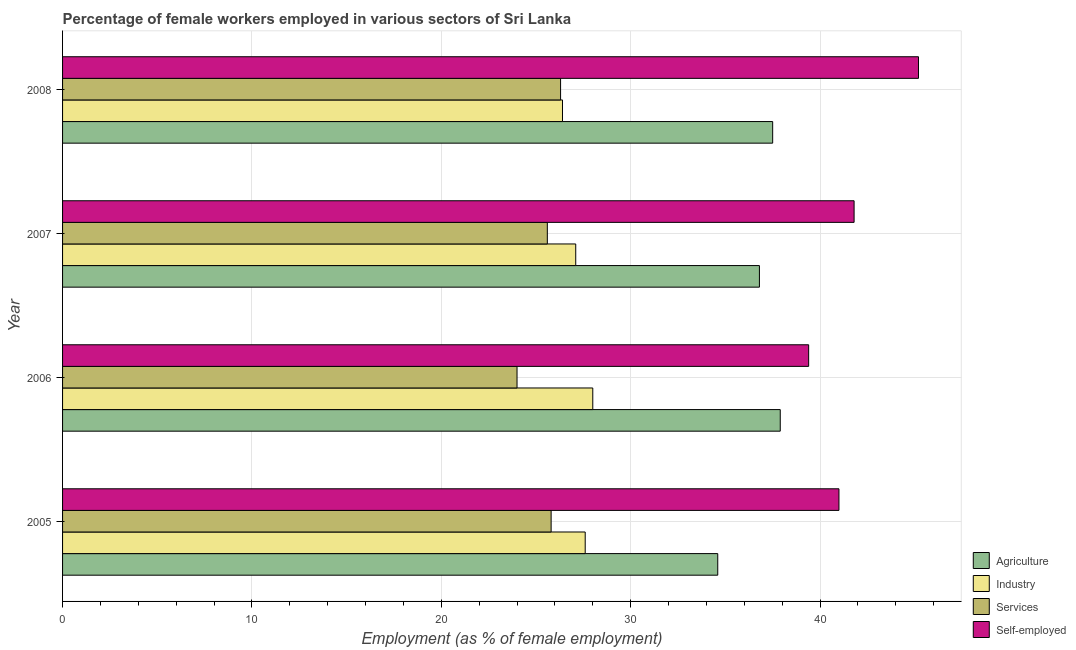How many different coloured bars are there?
Provide a succinct answer. 4. Are the number of bars per tick equal to the number of legend labels?
Offer a very short reply. Yes. What is the label of the 2nd group of bars from the top?
Offer a terse response. 2007. In how many cases, is the number of bars for a given year not equal to the number of legend labels?
Provide a succinct answer. 0. What is the percentage of female workers in services in 2006?
Your answer should be compact. 24. Across all years, what is the maximum percentage of female workers in services?
Keep it short and to the point. 26.3. Across all years, what is the minimum percentage of female workers in agriculture?
Give a very brief answer. 34.6. In which year was the percentage of self employed female workers maximum?
Offer a very short reply. 2008. What is the total percentage of self employed female workers in the graph?
Offer a terse response. 167.4. What is the difference between the percentage of self employed female workers in 2006 and the percentage of female workers in services in 2007?
Provide a succinct answer. 13.8. What is the average percentage of self employed female workers per year?
Make the answer very short. 41.85. In how many years, is the percentage of female workers in agriculture greater than 6 %?
Your response must be concise. 4. Is the percentage of female workers in agriculture in 2005 less than that in 2008?
Provide a succinct answer. Yes. What is the difference between the highest and the lowest percentage of female workers in services?
Give a very brief answer. 2.3. Is the sum of the percentage of female workers in industry in 2005 and 2007 greater than the maximum percentage of female workers in services across all years?
Make the answer very short. Yes. What does the 1st bar from the top in 2007 represents?
Provide a succinct answer. Self-employed. What does the 1st bar from the bottom in 2008 represents?
Keep it short and to the point. Agriculture. How many bars are there?
Ensure brevity in your answer.  16. How many years are there in the graph?
Make the answer very short. 4. What is the difference between two consecutive major ticks on the X-axis?
Your answer should be compact. 10. Are the values on the major ticks of X-axis written in scientific E-notation?
Ensure brevity in your answer.  No. Where does the legend appear in the graph?
Provide a short and direct response. Bottom right. How are the legend labels stacked?
Your response must be concise. Vertical. What is the title of the graph?
Offer a very short reply. Percentage of female workers employed in various sectors of Sri Lanka. What is the label or title of the X-axis?
Your answer should be compact. Employment (as % of female employment). What is the label or title of the Y-axis?
Keep it short and to the point. Year. What is the Employment (as % of female employment) of Agriculture in 2005?
Make the answer very short. 34.6. What is the Employment (as % of female employment) in Industry in 2005?
Your answer should be very brief. 27.6. What is the Employment (as % of female employment) in Services in 2005?
Offer a terse response. 25.8. What is the Employment (as % of female employment) of Self-employed in 2005?
Give a very brief answer. 41. What is the Employment (as % of female employment) of Agriculture in 2006?
Offer a very short reply. 37.9. What is the Employment (as % of female employment) of Industry in 2006?
Provide a short and direct response. 28. What is the Employment (as % of female employment) in Services in 2006?
Provide a succinct answer. 24. What is the Employment (as % of female employment) in Self-employed in 2006?
Make the answer very short. 39.4. What is the Employment (as % of female employment) in Agriculture in 2007?
Provide a succinct answer. 36.8. What is the Employment (as % of female employment) in Industry in 2007?
Offer a very short reply. 27.1. What is the Employment (as % of female employment) in Services in 2007?
Provide a succinct answer. 25.6. What is the Employment (as % of female employment) in Self-employed in 2007?
Provide a short and direct response. 41.8. What is the Employment (as % of female employment) in Agriculture in 2008?
Your answer should be compact. 37.5. What is the Employment (as % of female employment) in Industry in 2008?
Keep it short and to the point. 26.4. What is the Employment (as % of female employment) of Services in 2008?
Ensure brevity in your answer.  26.3. What is the Employment (as % of female employment) in Self-employed in 2008?
Provide a short and direct response. 45.2. Across all years, what is the maximum Employment (as % of female employment) of Agriculture?
Provide a succinct answer. 37.9. Across all years, what is the maximum Employment (as % of female employment) of Industry?
Your answer should be very brief. 28. Across all years, what is the maximum Employment (as % of female employment) in Services?
Provide a short and direct response. 26.3. Across all years, what is the maximum Employment (as % of female employment) of Self-employed?
Provide a succinct answer. 45.2. Across all years, what is the minimum Employment (as % of female employment) of Agriculture?
Ensure brevity in your answer.  34.6. Across all years, what is the minimum Employment (as % of female employment) in Industry?
Provide a short and direct response. 26.4. Across all years, what is the minimum Employment (as % of female employment) of Services?
Your answer should be compact. 24. Across all years, what is the minimum Employment (as % of female employment) of Self-employed?
Your answer should be very brief. 39.4. What is the total Employment (as % of female employment) in Agriculture in the graph?
Give a very brief answer. 146.8. What is the total Employment (as % of female employment) of Industry in the graph?
Your response must be concise. 109.1. What is the total Employment (as % of female employment) of Services in the graph?
Ensure brevity in your answer.  101.7. What is the total Employment (as % of female employment) of Self-employed in the graph?
Provide a succinct answer. 167.4. What is the difference between the Employment (as % of female employment) of Agriculture in 2005 and that in 2006?
Your answer should be compact. -3.3. What is the difference between the Employment (as % of female employment) in Industry in 2005 and that in 2006?
Make the answer very short. -0.4. What is the difference between the Employment (as % of female employment) in Services in 2005 and that in 2006?
Make the answer very short. 1.8. What is the difference between the Employment (as % of female employment) of Agriculture in 2005 and that in 2007?
Offer a very short reply. -2.2. What is the difference between the Employment (as % of female employment) of Industry in 2005 and that in 2007?
Make the answer very short. 0.5. What is the difference between the Employment (as % of female employment) of Self-employed in 2005 and that in 2007?
Keep it short and to the point. -0.8. What is the difference between the Employment (as % of female employment) of Agriculture in 2005 and that in 2008?
Offer a terse response. -2.9. What is the difference between the Employment (as % of female employment) of Services in 2005 and that in 2008?
Give a very brief answer. -0.5. What is the difference between the Employment (as % of female employment) in Agriculture in 2006 and that in 2007?
Give a very brief answer. 1.1. What is the difference between the Employment (as % of female employment) in Agriculture in 2006 and that in 2008?
Offer a terse response. 0.4. What is the difference between the Employment (as % of female employment) of Industry in 2006 and that in 2008?
Your response must be concise. 1.6. What is the difference between the Employment (as % of female employment) in Services in 2006 and that in 2008?
Offer a very short reply. -2.3. What is the difference between the Employment (as % of female employment) in Services in 2007 and that in 2008?
Keep it short and to the point. -0.7. What is the difference between the Employment (as % of female employment) of Agriculture in 2005 and the Employment (as % of female employment) of Services in 2006?
Your answer should be compact. 10.6. What is the difference between the Employment (as % of female employment) of Agriculture in 2005 and the Employment (as % of female employment) of Self-employed in 2006?
Offer a very short reply. -4.8. What is the difference between the Employment (as % of female employment) in Industry in 2005 and the Employment (as % of female employment) in Self-employed in 2006?
Provide a succinct answer. -11.8. What is the difference between the Employment (as % of female employment) in Services in 2005 and the Employment (as % of female employment) in Self-employed in 2006?
Provide a succinct answer. -13.6. What is the difference between the Employment (as % of female employment) of Industry in 2005 and the Employment (as % of female employment) of Services in 2007?
Ensure brevity in your answer.  2. What is the difference between the Employment (as % of female employment) of Industry in 2005 and the Employment (as % of female employment) of Self-employed in 2007?
Offer a terse response. -14.2. What is the difference between the Employment (as % of female employment) of Services in 2005 and the Employment (as % of female employment) of Self-employed in 2007?
Give a very brief answer. -16. What is the difference between the Employment (as % of female employment) of Agriculture in 2005 and the Employment (as % of female employment) of Industry in 2008?
Ensure brevity in your answer.  8.2. What is the difference between the Employment (as % of female employment) in Agriculture in 2005 and the Employment (as % of female employment) in Services in 2008?
Your answer should be very brief. 8.3. What is the difference between the Employment (as % of female employment) in Agriculture in 2005 and the Employment (as % of female employment) in Self-employed in 2008?
Ensure brevity in your answer.  -10.6. What is the difference between the Employment (as % of female employment) of Industry in 2005 and the Employment (as % of female employment) of Services in 2008?
Keep it short and to the point. 1.3. What is the difference between the Employment (as % of female employment) of Industry in 2005 and the Employment (as % of female employment) of Self-employed in 2008?
Your response must be concise. -17.6. What is the difference between the Employment (as % of female employment) in Services in 2005 and the Employment (as % of female employment) in Self-employed in 2008?
Offer a terse response. -19.4. What is the difference between the Employment (as % of female employment) of Agriculture in 2006 and the Employment (as % of female employment) of Self-employed in 2007?
Your response must be concise. -3.9. What is the difference between the Employment (as % of female employment) of Industry in 2006 and the Employment (as % of female employment) of Self-employed in 2007?
Provide a short and direct response. -13.8. What is the difference between the Employment (as % of female employment) in Services in 2006 and the Employment (as % of female employment) in Self-employed in 2007?
Give a very brief answer. -17.8. What is the difference between the Employment (as % of female employment) of Agriculture in 2006 and the Employment (as % of female employment) of Services in 2008?
Provide a succinct answer. 11.6. What is the difference between the Employment (as % of female employment) in Industry in 2006 and the Employment (as % of female employment) in Services in 2008?
Your answer should be compact. 1.7. What is the difference between the Employment (as % of female employment) of Industry in 2006 and the Employment (as % of female employment) of Self-employed in 2008?
Your answer should be compact. -17.2. What is the difference between the Employment (as % of female employment) of Services in 2006 and the Employment (as % of female employment) of Self-employed in 2008?
Offer a terse response. -21.2. What is the difference between the Employment (as % of female employment) in Agriculture in 2007 and the Employment (as % of female employment) in Industry in 2008?
Your answer should be very brief. 10.4. What is the difference between the Employment (as % of female employment) in Industry in 2007 and the Employment (as % of female employment) in Self-employed in 2008?
Provide a succinct answer. -18.1. What is the difference between the Employment (as % of female employment) in Services in 2007 and the Employment (as % of female employment) in Self-employed in 2008?
Keep it short and to the point. -19.6. What is the average Employment (as % of female employment) of Agriculture per year?
Your answer should be compact. 36.7. What is the average Employment (as % of female employment) in Industry per year?
Make the answer very short. 27.27. What is the average Employment (as % of female employment) in Services per year?
Your response must be concise. 25.43. What is the average Employment (as % of female employment) of Self-employed per year?
Offer a terse response. 41.85. In the year 2005, what is the difference between the Employment (as % of female employment) of Agriculture and Employment (as % of female employment) of Industry?
Your answer should be compact. 7. In the year 2005, what is the difference between the Employment (as % of female employment) of Agriculture and Employment (as % of female employment) of Services?
Your answer should be compact. 8.8. In the year 2005, what is the difference between the Employment (as % of female employment) in Agriculture and Employment (as % of female employment) in Self-employed?
Provide a short and direct response. -6.4. In the year 2005, what is the difference between the Employment (as % of female employment) of Industry and Employment (as % of female employment) of Services?
Your answer should be very brief. 1.8. In the year 2005, what is the difference between the Employment (as % of female employment) of Services and Employment (as % of female employment) of Self-employed?
Give a very brief answer. -15.2. In the year 2006, what is the difference between the Employment (as % of female employment) of Agriculture and Employment (as % of female employment) of Industry?
Your answer should be very brief. 9.9. In the year 2006, what is the difference between the Employment (as % of female employment) in Agriculture and Employment (as % of female employment) in Services?
Your answer should be very brief. 13.9. In the year 2006, what is the difference between the Employment (as % of female employment) of Agriculture and Employment (as % of female employment) of Self-employed?
Keep it short and to the point. -1.5. In the year 2006, what is the difference between the Employment (as % of female employment) in Services and Employment (as % of female employment) in Self-employed?
Offer a very short reply. -15.4. In the year 2007, what is the difference between the Employment (as % of female employment) of Agriculture and Employment (as % of female employment) of Industry?
Ensure brevity in your answer.  9.7. In the year 2007, what is the difference between the Employment (as % of female employment) of Agriculture and Employment (as % of female employment) of Self-employed?
Give a very brief answer. -5. In the year 2007, what is the difference between the Employment (as % of female employment) of Industry and Employment (as % of female employment) of Self-employed?
Your response must be concise. -14.7. In the year 2007, what is the difference between the Employment (as % of female employment) in Services and Employment (as % of female employment) in Self-employed?
Give a very brief answer. -16.2. In the year 2008, what is the difference between the Employment (as % of female employment) in Agriculture and Employment (as % of female employment) in Services?
Offer a terse response. 11.2. In the year 2008, what is the difference between the Employment (as % of female employment) of Agriculture and Employment (as % of female employment) of Self-employed?
Offer a terse response. -7.7. In the year 2008, what is the difference between the Employment (as % of female employment) of Industry and Employment (as % of female employment) of Self-employed?
Your answer should be very brief. -18.8. In the year 2008, what is the difference between the Employment (as % of female employment) of Services and Employment (as % of female employment) of Self-employed?
Give a very brief answer. -18.9. What is the ratio of the Employment (as % of female employment) of Agriculture in 2005 to that in 2006?
Ensure brevity in your answer.  0.91. What is the ratio of the Employment (as % of female employment) of Industry in 2005 to that in 2006?
Give a very brief answer. 0.99. What is the ratio of the Employment (as % of female employment) in Services in 2005 to that in 2006?
Keep it short and to the point. 1.07. What is the ratio of the Employment (as % of female employment) in Self-employed in 2005 to that in 2006?
Offer a very short reply. 1.04. What is the ratio of the Employment (as % of female employment) in Agriculture in 2005 to that in 2007?
Keep it short and to the point. 0.94. What is the ratio of the Employment (as % of female employment) in Industry in 2005 to that in 2007?
Your answer should be very brief. 1.02. What is the ratio of the Employment (as % of female employment) of Services in 2005 to that in 2007?
Provide a succinct answer. 1.01. What is the ratio of the Employment (as % of female employment) of Self-employed in 2005 to that in 2007?
Your answer should be very brief. 0.98. What is the ratio of the Employment (as % of female employment) in Agriculture in 2005 to that in 2008?
Provide a short and direct response. 0.92. What is the ratio of the Employment (as % of female employment) of Industry in 2005 to that in 2008?
Provide a short and direct response. 1.05. What is the ratio of the Employment (as % of female employment) of Services in 2005 to that in 2008?
Make the answer very short. 0.98. What is the ratio of the Employment (as % of female employment) in Self-employed in 2005 to that in 2008?
Make the answer very short. 0.91. What is the ratio of the Employment (as % of female employment) of Agriculture in 2006 to that in 2007?
Your answer should be very brief. 1.03. What is the ratio of the Employment (as % of female employment) in Industry in 2006 to that in 2007?
Ensure brevity in your answer.  1.03. What is the ratio of the Employment (as % of female employment) of Services in 2006 to that in 2007?
Give a very brief answer. 0.94. What is the ratio of the Employment (as % of female employment) in Self-employed in 2006 to that in 2007?
Make the answer very short. 0.94. What is the ratio of the Employment (as % of female employment) in Agriculture in 2006 to that in 2008?
Your answer should be compact. 1.01. What is the ratio of the Employment (as % of female employment) of Industry in 2006 to that in 2008?
Provide a succinct answer. 1.06. What is the ratio of the Employment (as % of female employment) in Services in 2006 to that in 2008?
Give a very brief answer. 0.91. What is the ratio of the Employment (as % of female employment) in Self-employed in 2006 to that in 2008?
Your response must be concise. 0.87. What is the ratio of the Employment (as % of female employment) of Agriculture in 2007 to that in 2008?
Your answer should be compact. 0.98. What is the ratio of the Employment (as % of female employment) in Industry in 2007 to that in 2008?
Your answer should be compact. 1.03. What is the ratio of the Employment (as % of female employment) in Services in 2007 to that in 2008?
Make the answer very short. 0.97. What is the ratio of the Employment (as % of female employment) in Self-employed in 2007 to that in 2008?
Your answer should be very brief. 0.92. What is the difference between the highest and the second highest Employment (as % of female employment) in Agriculture?
Your response must be concise. 0.4. What is the difference between the highest and the second highest Employment (as % of female employment) of Industry?
Give a very brief answer. 0.4. What is the difference between the highest and the second highest Employment (as % of female employment) in Services?
Provide a succinct answer. 0.5. What is the difference between the highest and the second highest Employment (as % of female employment) of Self-employed?
Your answer should be very brief. 3.4. What is the difference between the highest and the lowest Employment (as % of female employment) of Agriculture?
Your answer should be very brief. 3.3. What is the difference between the highest and the lowest Employment (as % of female employment) in Services?
Make the answer very short. 2.3. 